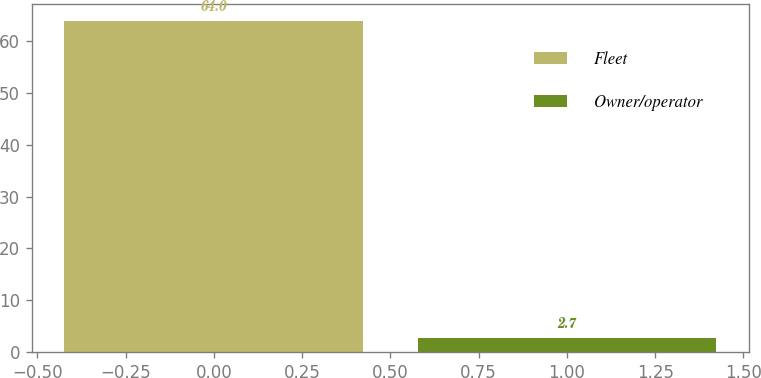Convert chart to OTSL. <chart><loc_0><loc_0><loc_500><loc_500><bar_chart><fcel>Fleet<fcel>Owner/operator<nl><fcel>64<fcel>2.7<nl></chart> 